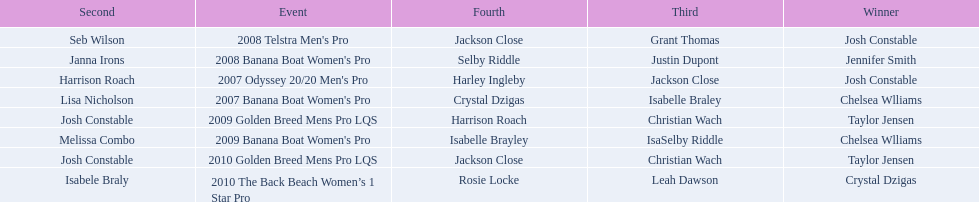Name each of the years that taylor jensen was winner. 2009, 2010. 